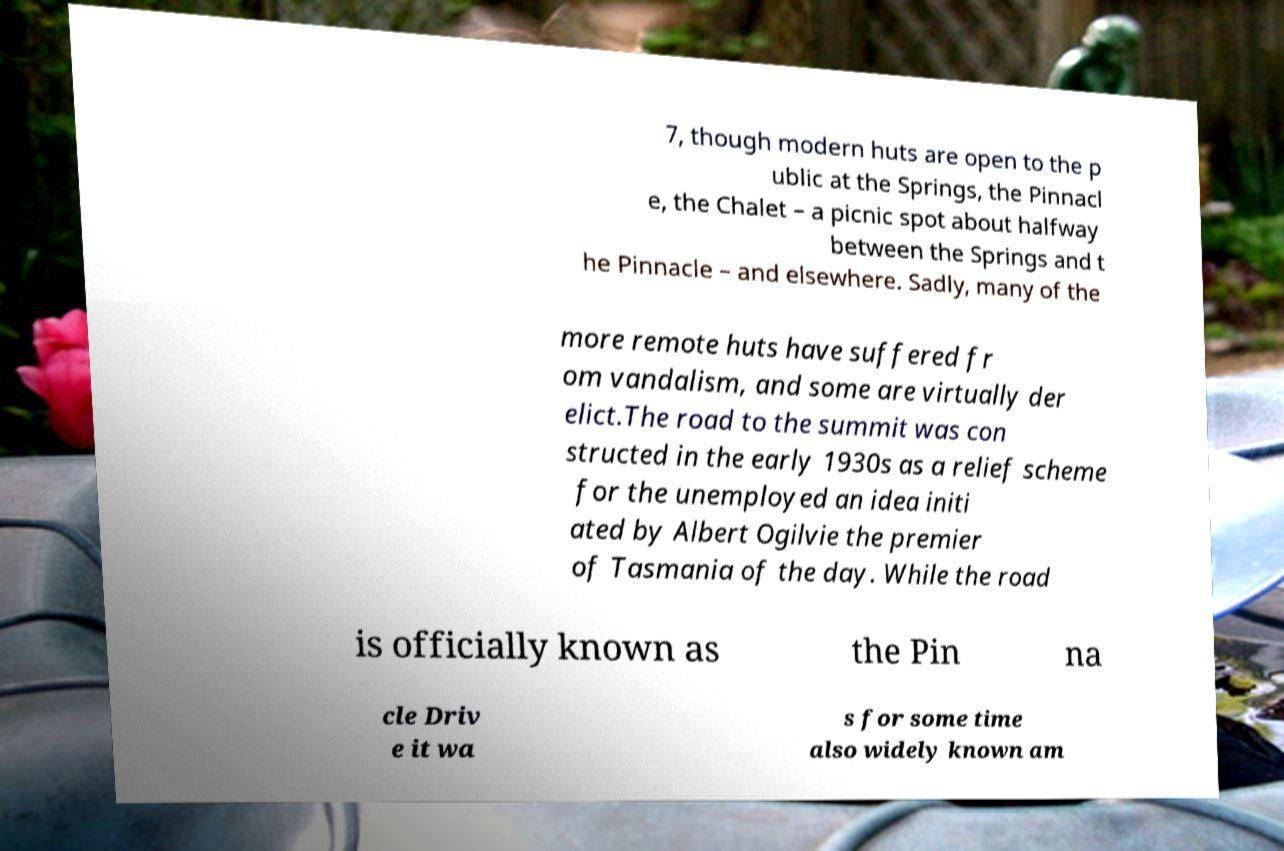Please read and relay the text visible in this image. What does it say? 7, though modern huts are open to the p ublic at the Springs, the Pinnacl e, the Chalet – a picnic spot about halfway between the Springs and t he Pinnacle – and elsewhere. Sadly, many of the more remote huts have suffered fr om vandalism, and some are virtually der elict.The road to the summit was con structed in the early 1930s as a relief scheme for the unemployed an idea initi ated by Albert Ogilvie the premier of Tasmania of the day. While the road is officially known as the Pin na cle Driv e it wa s for some time also widely known am 